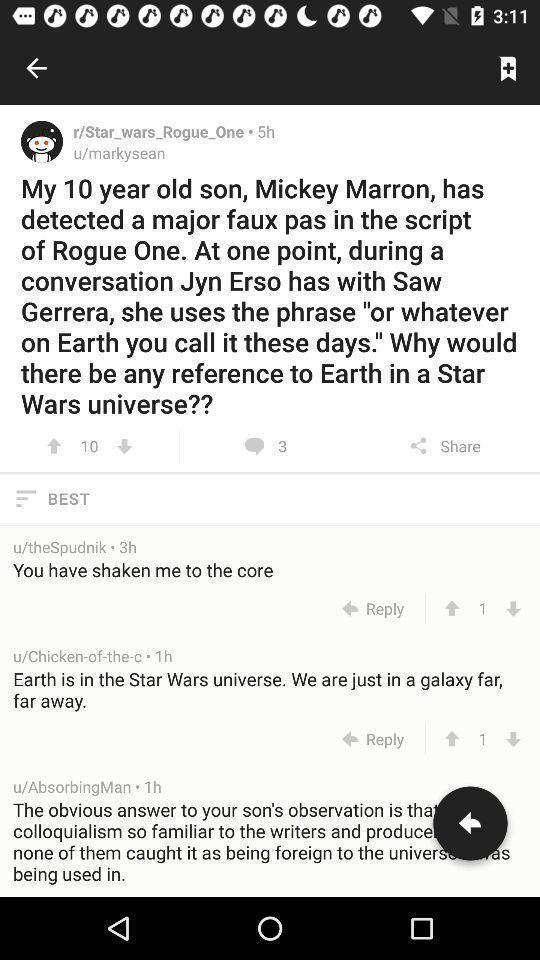Describe the key features of this screenshot. Screen showing question and answers. 